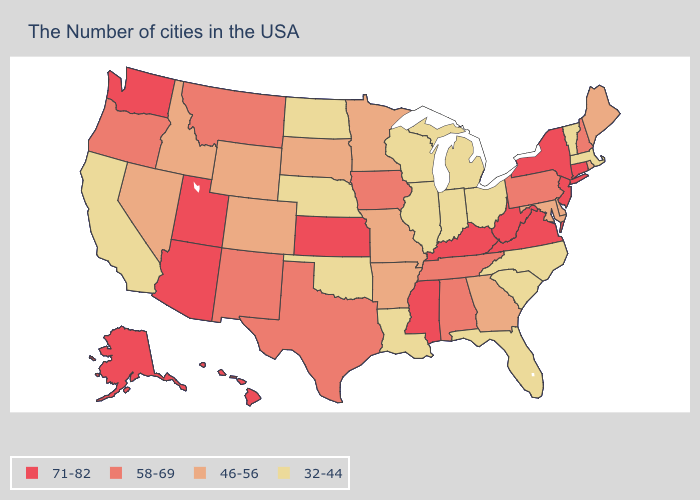Which states have the lowest value in the Northeast?
Write a very short answer. Massachusetts, Vermont. What is the value of Illinois?
Concise answer only. 32-44. Name the states that have a value in the range 32-44?
Give a very brief answer. Massachusetts, Vermont, North Carolina, South Carolina, Ohio, Florida, Michigan, Indiana, Wisconsin, Illinois, Louisiana, Nebraska, Oklahoma, North Dakota, California. What is the value of Nevada?
Keep it brief. 46-56. Does Massachusetts have the lowest value in the Northeast?
Keep it brief. Yes. Which states have the highest value in the USA?
Quick response, please. Connecticut, New York, New Jersey, Virginia, West Virginia, Kentucky, Mississippi, Kansas, Utah, Arizona, Washington, Alaska, Hawaii. Name the states that have a value in the range 46-56?
Write a very short answer. Maine, Rhode Island, Delaware, Maryland, Georgia, Missouri, Arkansas, Minnesota, South Dakota, Wyoming, Colorado, Idaho, Nevada. Which states have the lowest value in the West?
Answer briefly. California. What is the lowest value in the Northeast?
Answer briefly. 32-44. What is the value of Hawaii?
Quick response, please. 71-82. What is the value of Connecticut?
Be succinct. 71-82. What is the highest value in states that border New Jersey?
Short answer required. 71-82. Does South Carolina have a lower value than North Carolina?
Write a very short answer. No. Does West Virginia have the highest value in the South?
Be succinct. Yes. 